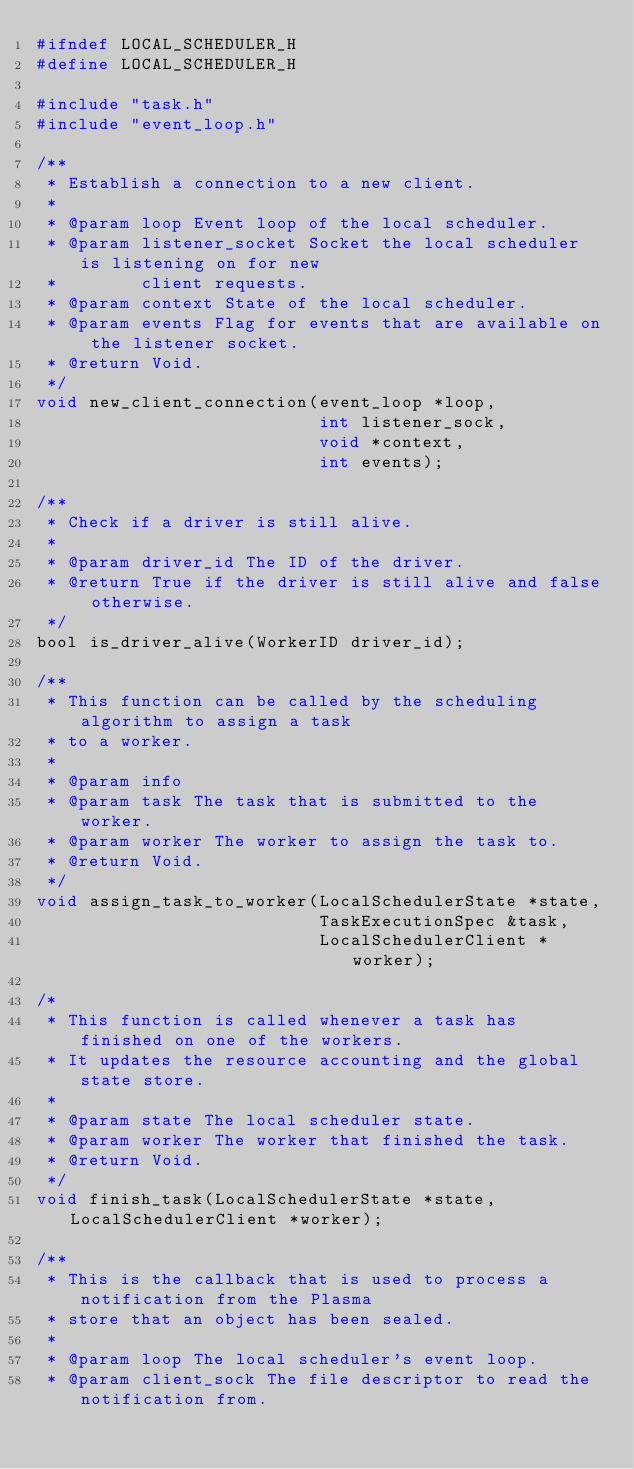Convert code to text. <code><loc_0><loc_0><loc_500><loc_500><_C_>#ifndef LOCAL_SCHEDULER_H
#define LOCAL_SCHEDULER_H

#include "task.h"
#include "event_loop.h"

/**
 * Establish a connection to a new client.
 *
 * @param loop Event loop of the local scheduler.
 * @param listener_socket Socket the local scheduler is listening on for new
 *        client requests.
 * @param context State of the local scheduler.
 * @param events Flag for events that are available on the listener socket.
 * @return Void.
 */
void new_client_connection(event_loop *loop,
                           int listener_sock,
                           void *context,
                           int events);

/**
 * Check if a driver is still alive.
 *
 * @param driver_id The ID of the driver.
 * @return True if the driver is still alive and false otherwise.
 */
bool is_driver_alive(WorkerID driver_id);

/**
 * This function can be called by the scheduling algorithm to assign a task
 * to a worker.
 *
 * @param info
 * @param task The task that is submitted to the worker.
 * @param worker The worker to assign the task to.
 * @return Void.
 */
void assign_task_to_worker(LocalSchedulerState *state,
                           TaskExecutionSpec &task,
                           LocalSchedulerClient *worker);

/*
 * This function is called whenever a task has finished on one of the workers.
 * It updates the resource accounting and the global state store.
 *
 * @param state The local scheduler state.
 * @param worker The worker that finished the task.
 * @return Void.
 */
void finish_task(LocalSchedulerState *state, LocalSchedulerClient *worker);

/**
 * This is the callback that is used to process a notification from the Plasma
 * store that an object has been sealed.
 *
 * @param loop The local scheduler's event loop.
 * @param client_sock The file descriptor to read the notification from.</code> 